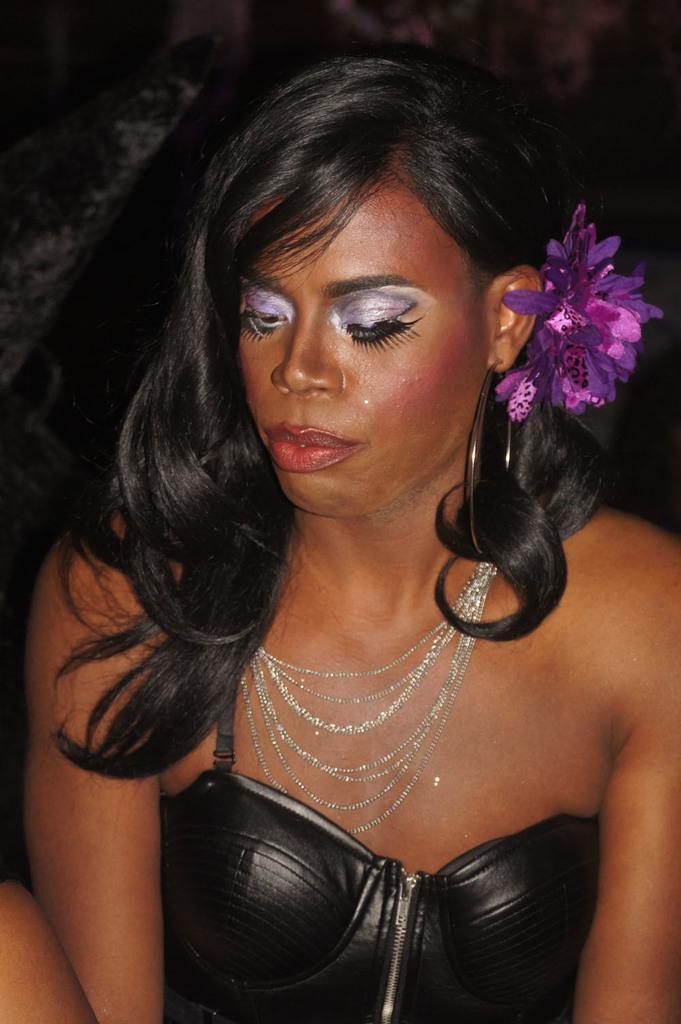How would you summarize this image in a sentence or two? In this image, we can see a woman, she is wearing a black dress, there is a dark background. 